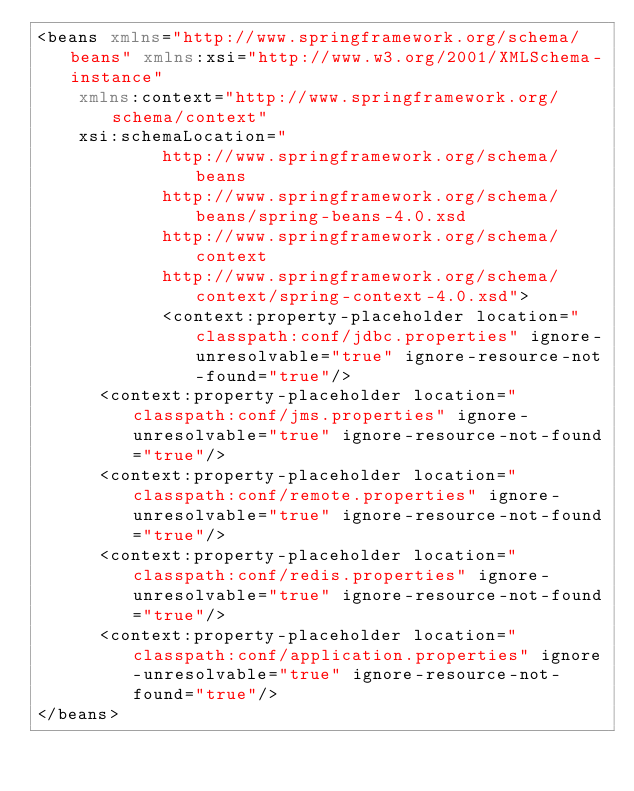<code> <loc_0><loc_0><loc_500><loc_500><_XML_><beans xmlns="http://www.springframework.org/schema/beans" xmlns:xsi="http://www.w3.org/2001/XMLSchema-instance"
    xmlns:context="http://www.springframework.org/schema/context"
    xsi:schemaLocation="
            http://www.springframework.org/schema/beans
            http://www.springframework.org/schema/beans/spring-beans-4.0.xsd
            http://www.springframework.org/schema/context
            http://www.springframework.org/schema/context/spring-context-4.0.xsd">
            <context:property-placeholder location="classpath:conf/jdbc.properties" ignore-unresolvable="true" ignore-resource-not-found="true"/>
			<context:property-placeholder location="classpath:conf/jms.properties" ignore-unresolvable="true" ignore-resource-not-found="true"/>
			<context:property-placeholder location="classpath:conf/remote.properties" ignore-unresolvable="true" ignore-resource-not-found="true"/>
			<context:property-placeholder location="classpath:conf/redis.properties" ignore-unresolvable="true" ignore-resource-not-found="true"/>
			<context:property-placeholder location="classpath:conf/application.properties" ignore-unresolvable="true" ignore-resource-not-found="true"/>
</beans>
</code> 